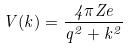Convert formula to latex. <formula><loc_0><loc_0><loc_500><loc_500>V ( k ) = \frac { 4 \pi Z e } { q ^ { 2 } + k ^ { 2 } }</formula> 